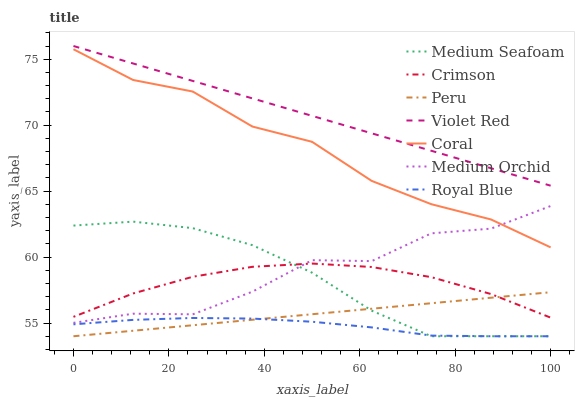Does Royal Blue have the minimum area under the curve?
Answer yes or no. Yes. Does Violet Red have the maximum area under the curve?
Answer yes or no. Yes. Does Coral have the minimum area under the curve?
Answer yes or no. No. Does Coral have the maximum area under the curve?
Answer yes or no. No. Is Peru the smoothest?
Answer yes or no. Yes. Is Medium Orchid the roughest?
Answer yes or no. Yes. Is Coral the smoothest?
Answer yes or no. No. Is Coral the roughest?
Answer yes or no. No. Does Coral have the lowest value?
Answer yes or no. No. Does Violet Red have the highest value?
Answer yes or no. Yes. Does Coral have the highest value?
Answer yes or no. No. Is Royal Blue less than Crimson?
Answer yes or no. Yes. Is Coral greater than Crimson?
Answer yes or no. Yes. Does Coral intersect Medium Orchid?
Answer yes or no. Yes. Is Coral less than Medium Orchid?
Answer yes or no. No. Is Coral greater than Medium Orchid?
Answer yes or no. No. Does Royal Blue intersect Crimson?
Answer yes or no. No. 